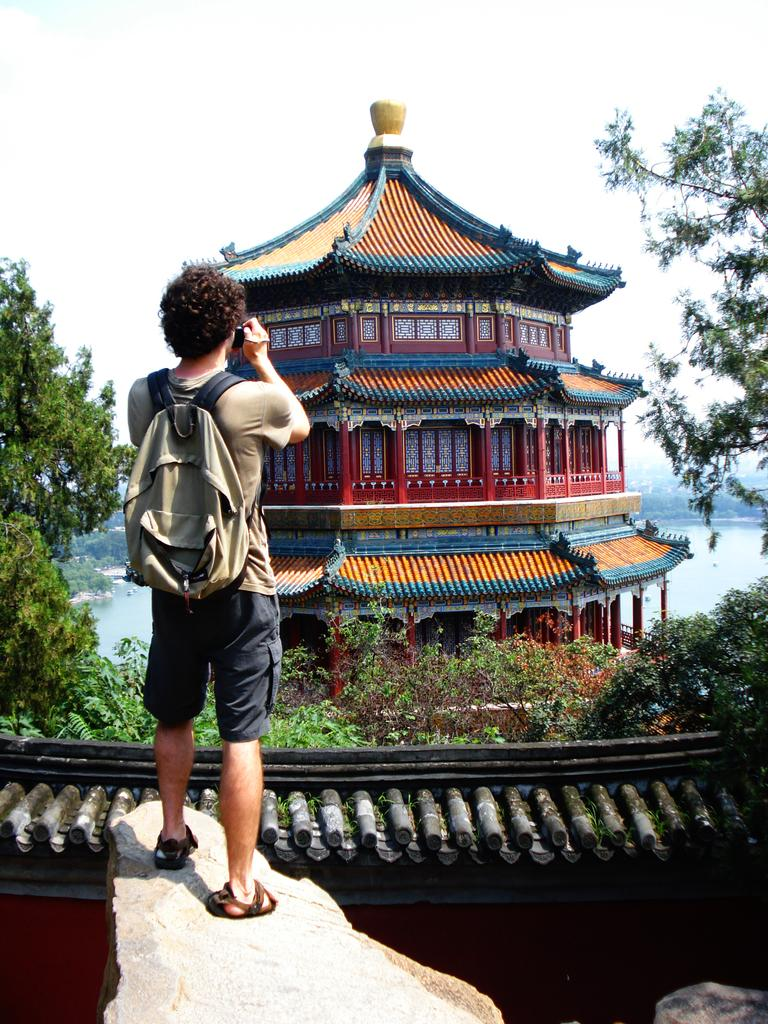What structure is present in the image? There is a building in the image. Where is the person located in the image? The person is standing on a rock in the image. What is the person holding in their hand? The person is holding a camera in their hand. What type of vegetation can be seen in the image? There are trees in the image. What natural element is visible in the image? There is water visible in the image. What is visible in the background of the image? The sky is visible in the image. How does the person measure the distance between the building and the trees in the image? There is no indication in the image that the person is measuring any distances. What type of stone is the person standing on in the image? The type of rock the person is standing on is not specified in the image. 